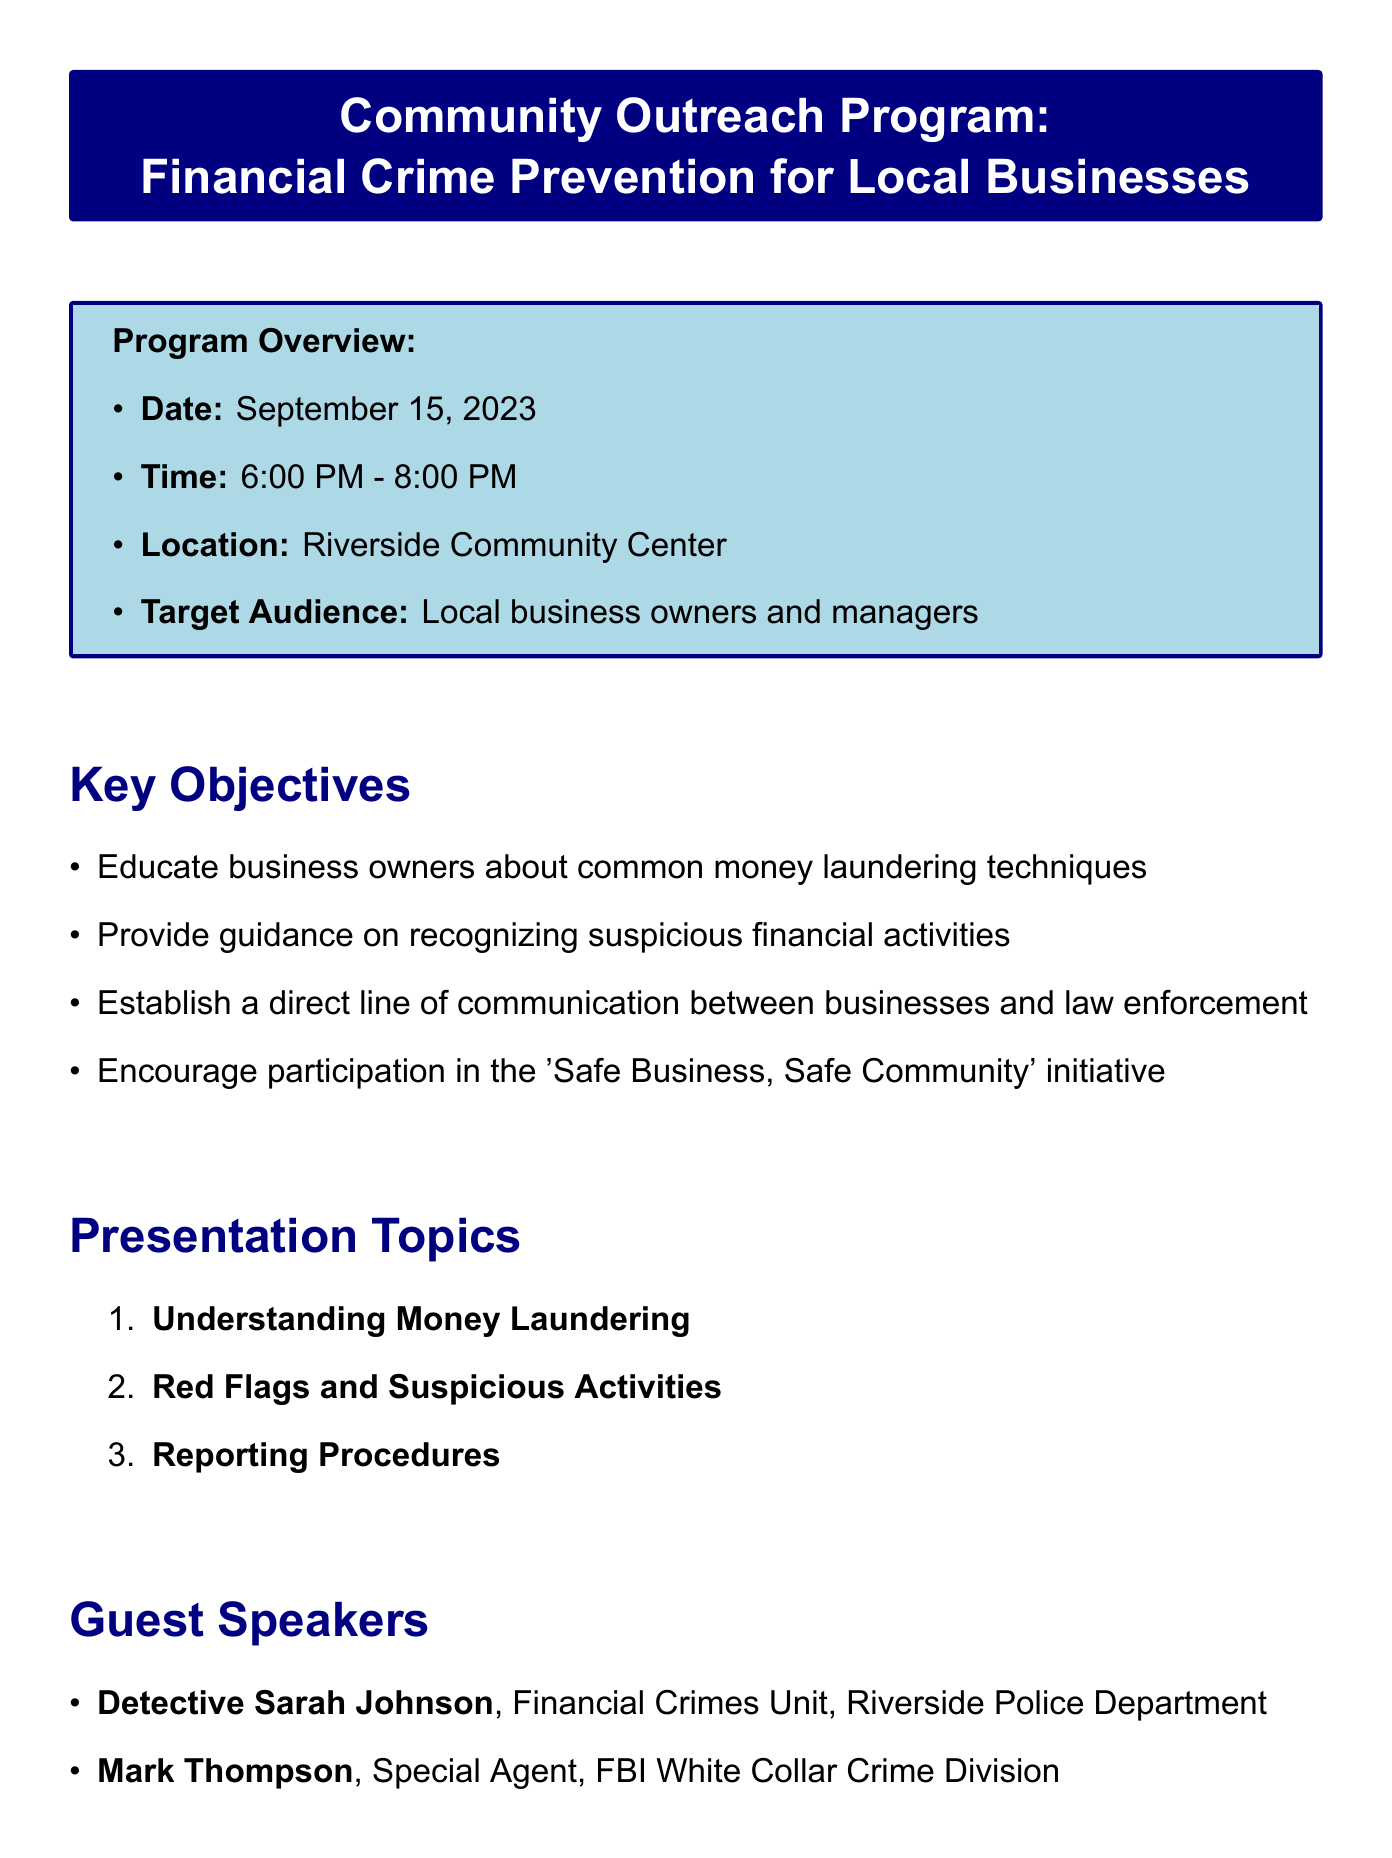What is the date of the program? The date of the program is clearly mentioned in the document under the program overview section.
Answer: September 15, 2023 What time does the program start? The start time of the program is stated alongside the date in the program overview section.
Answer: 6:00 PM Who is the program coordinator? The contact information section specifies the person in charge of the program coordination.
Answer: Officer Michael Chen What is one of the key objectives of the program? The key objectives are listed, focusing on educational goals related to financial crime prevention.
Answer: Educate business owners about common money laundering techniques Who is one of the guest speakers? The guest speakers are listed; their names and titles are provided in the corresponding section.
Answer: Detective Sarah Johnson What is one of the high-risk sectors mentioned? The local context section lists high-risk sectors susceptible to financial crimes.
Answer: Cash-intensive businesses What is the location of the event? The location is a part of the program overview detailing where the outreach will occur.
Answer: Riverside Community Center What will be distributed to attendees? The follow-up actions section mentions specific materials that will be provided during the program.
Answer: Financial Crime Prevention Toolkit 